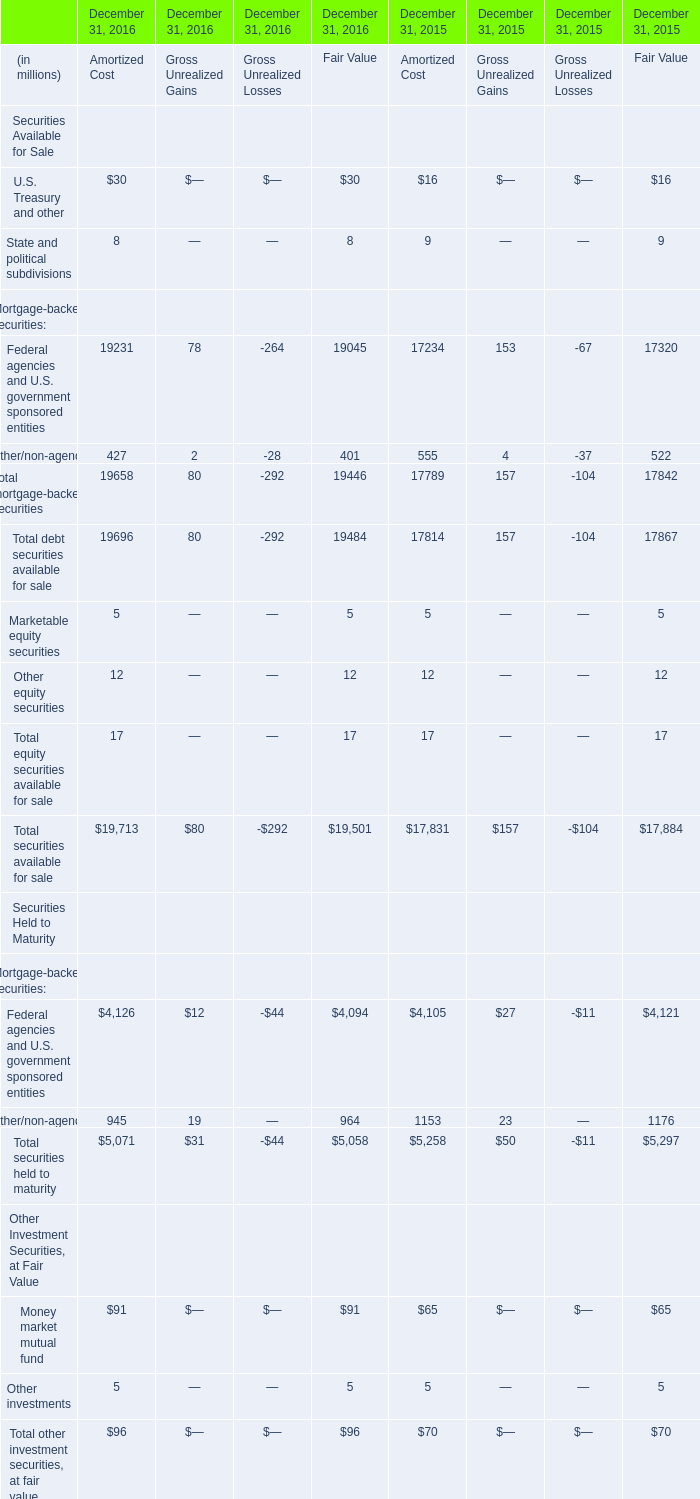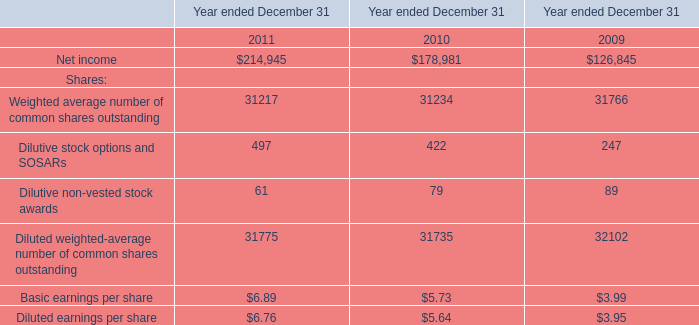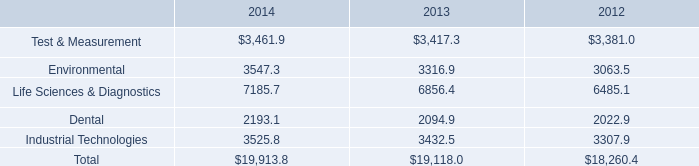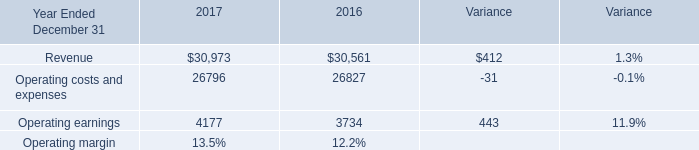Which Federal agencies and U.S. government sponsored entities exceeds 50 % of total in 2016? 
Answer: Amortized Cost, Fair Value. 